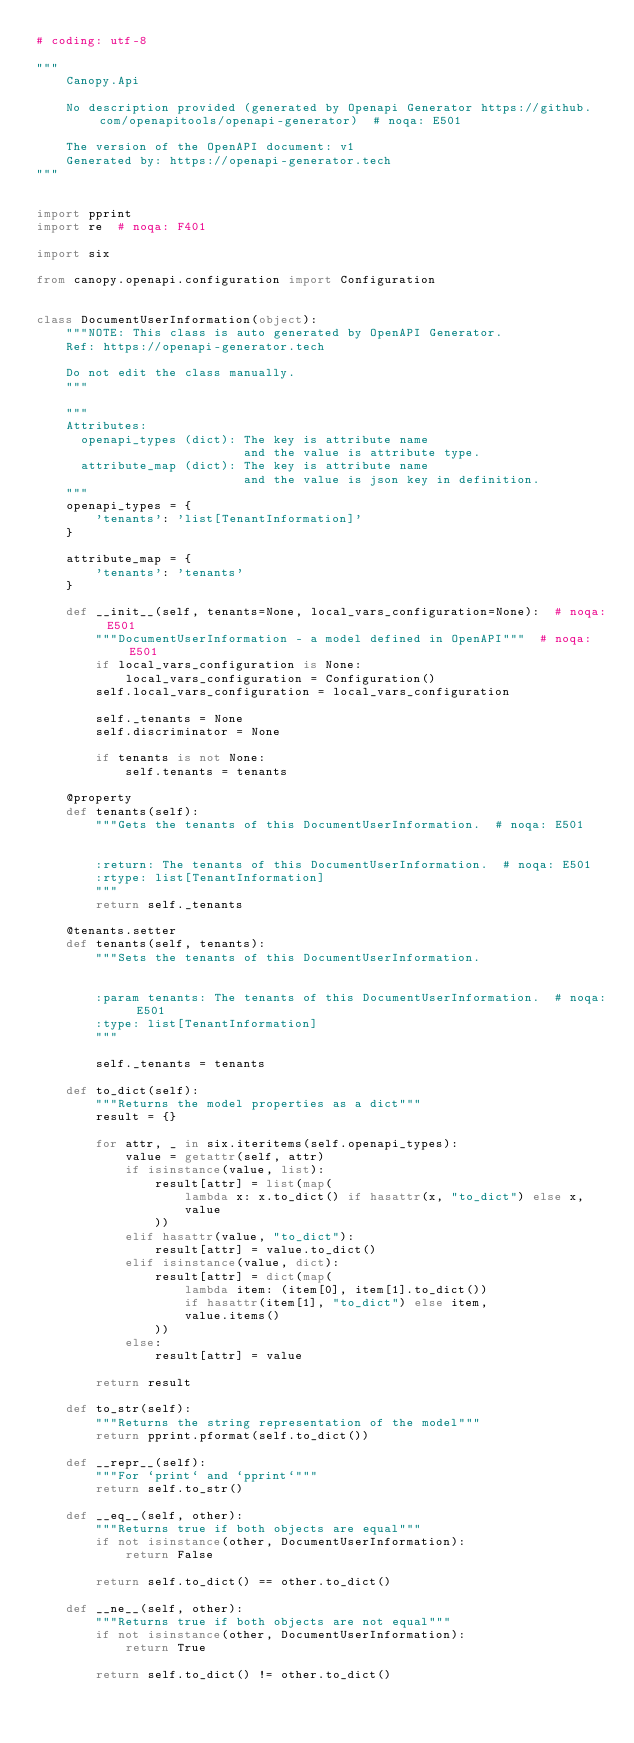Convert code to text. <code><loc_0><loc_0><loc_500><loc_500><_Python_># coding: utf-8

"""
    Canopy.Api

    No description provided (generated by Openapi Generator https://github.com/openapitools/openapi-generator)  # noqa: E501

    The version of the OpenAPI document: v1
    Generated by: https://openapi-generator.tech
"""


import pprint
import re  # noqa: F401

import six

from canopy.openapi.configuration import Configuration


class DocumentUserInformation(object):
    """NOTE: This class is auto generated by OpenAPI Generator.
    Ref: https://openapi-generator.tech

    Do not edit the class manually.
    """

    """
    Attributes:
      openapi_types (dict): The key is attribute name
                            and the value is attribute type.
      attribute_map (dict): The key is attribute name
                            and the value is json key in definition.
    """
    openapi_types = {
        'tenants': 'list[TenantInformation]'
    }

    attribute_map = {
        'tenants': 'tenants'
    }

    def __init__(self, tenants=None, local_vars_configuration=None):  # noqa: E501
        """DocumentUserInformation - a model defined in OpenAPI"""  # noqa: E501
        if local_vars_configuration is None:
            local_vars_configuration = Configuration()
        self.local_vars_configuration = local_vars_configuration

        self._tenants = None
        self.discriminator = None

        if tenants is not None:
            self.tenants = tenants

    @property
    def tenants(self):
        """Gets the tenants of this DocumentUserInformation.  # noqa: E501


        :return: The tenants of this DocumentUserInformation.  # noqa: E501
        :rtype: list[TenantInformation]
        """
        return self._tenants

    @tenants.setter
    def tenants(self, tenants):
        """Sets the tenants of this DocumentUserInformation.


        :param tenants: The tenants of this DocumentUserInformation.  # noqa: E501
        :type: list[TenantInformation]
        """

        self._tenants = tenants

    def to_dict(self):
        """Returns the model properties as a dict"""
        result = {}

        for attr, _ in six.iteritems(self.openapi_types):
            value = getattr(self, attr)
            if isinstance(value, list):
                result[attr] = list(map(
                    lambda x: x.to_dict() if hasattr(x, "to_dict") else x,
                    value
                ))
            elif hasattr(value, "to_dict"):
                result[attr] = value.to_dict()
            elif isinstance(value, dict):
                result[attr] = dict(map(
                    lambda item: (item[0], item[1].to_dict())
                    if hasattr(item[1], "to_dict") else item,
                    value.items()
                ))
            else:
                result[attr] = value

        return result

    def to_str(self):
        """Returns the string representation of the model"""
        return pprint.pformat(self.to_dict())

    def __repr__(self):
        """For `print` and `pprint`"""
        return self.to_str()

    def __eq__(self, other):
        """Returns true if both objects are equal"""
        if not isinstance(other, DocumentUserInformation):
            return False

        return self.to_dict() == other.to_dict()

    def __ne__(self, other):
        """Returns true if both objects are not equal"""
        if not isinstance(other, DocumentUserInformation):
            return True

        return self.to_dict() != other.to_dict()
</code> 